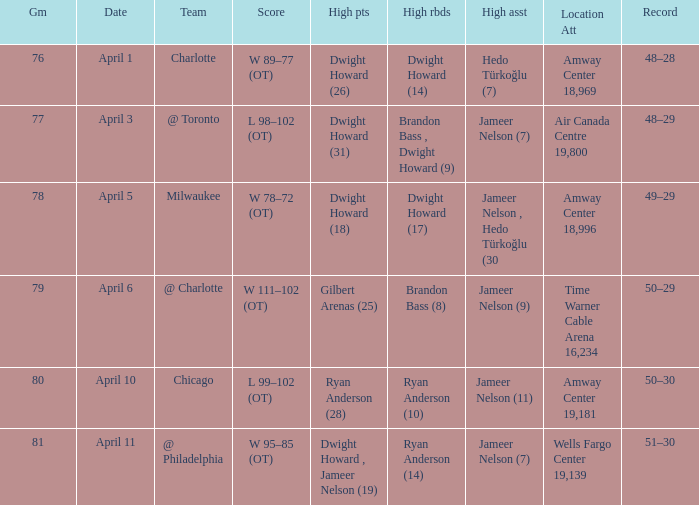Where was the game and what was the attendance on April 3?  Air Canada Centre 19,800. 